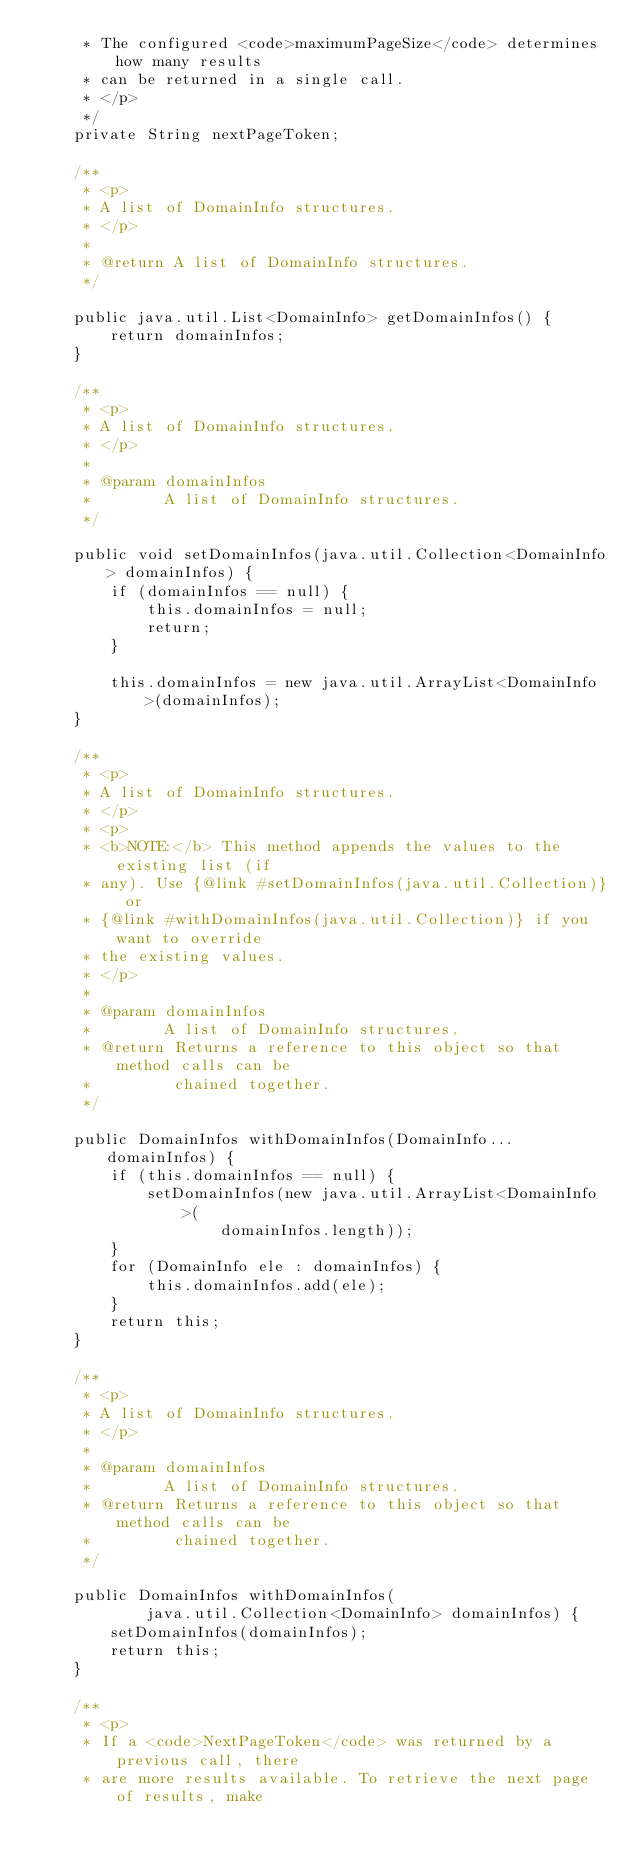Convert code to text. <code><loc_0><loc_0><loc_500><loc_500><_Java_>     * The configured <code>maximumPageSize</code> determines how many results
     * can be returned in a single call.
     * </p>
     */
    private String nextPageToken;

    /**
     * <p>
     * A list of DomainInfo structures.
     * </p>
     * 
     * @return A list of DomainInfo structures.
     */

    public java.util.List<DomainInfo> getDomainInfos() {
        return domainInfos;
    }

    /**
     * <p>
     * A list of DomainInfo structures.
     * </p>
     * 
     * @param domainInfos
     *        A list of DomainInfo structures.
     */

    public void setDomainInfos(java.util.Collection<DomainInfo> domainInfos) {
        if (domainInfos == null) {
            this.domainInfos = null;
            return;
        }

        this.domainInfos = new java.util.ArrayList<DomainInfo>(domainInfos);
    }

    /**
     * <p>
     * A list of DomainInfo structures.
     * </p>
     * <p>
     * <b>NOTE:</b> This method appends the values to the existing list (if
     * any). Use {@link #setDomainInfos(java.util.Collection)} or
     * {@link #withDomainInfos(java.util.Collection)} if you want to override
     * the existing values.
     * </p>
     * 
     * @param domainInfos
     *        A list of DomainInfo structures.
     * @return Returns a reference to this object so that method calls can be
     *         chained together.
     */

    public DomainInfos withDomainInfos(DomainInfo... domainInfos) {
        if (this.domainInfos == null) {
            setDomainInfos(new java.util.ArrayList<DomainInfo>(
                    domainInfos.length));
        }
        for (DomainInfo ele : domainInfos) {
            this.domainInfos.add(ele);
        }
        return this;
    }

    /**
     * <p>
     * A list of DomainInfo structures.
     * </p>
     * 
     * @param domainInfos
     *        A list of DomainInfo structures.
     * @return Returns a reference to this object so that method calls can be
     *         chained together.
     */

    public DomainInfos withDomainInfos(
            java.util.Collection<DomainInfo> domainInfos) {
        setDomainInfos(domainInfos);
        return this;
    }

    /**
     * <p>
     * If a <code>NextPageToken</code> was returned by a previous call, there
     * are more results available. To retrieve the next page of results, make</code> 